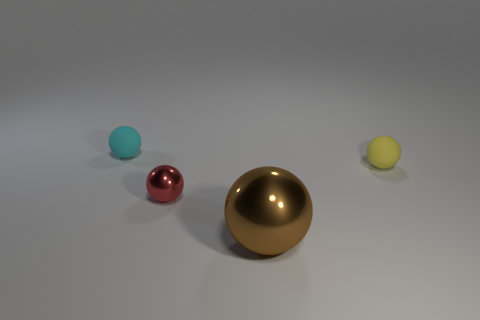Could you tell me the possible materials each of the balls are made from? Certainly, based on their appearance, from left to right: the first ball seems to have a matte, possibly plastic surface; the second is shiny and reflective, potentially a polished metal; the large ball in the center appears to have a golden metallic finish; and the far-right ball could be a matte-finished surface, potentially a different type of plastic or a rubber material. 